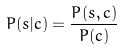<formula> <loc_0><loc_0><loc_500><loc_500>P ( s | c ) = \frac { P ( s , c ) } { P ( c ) }</formula> 